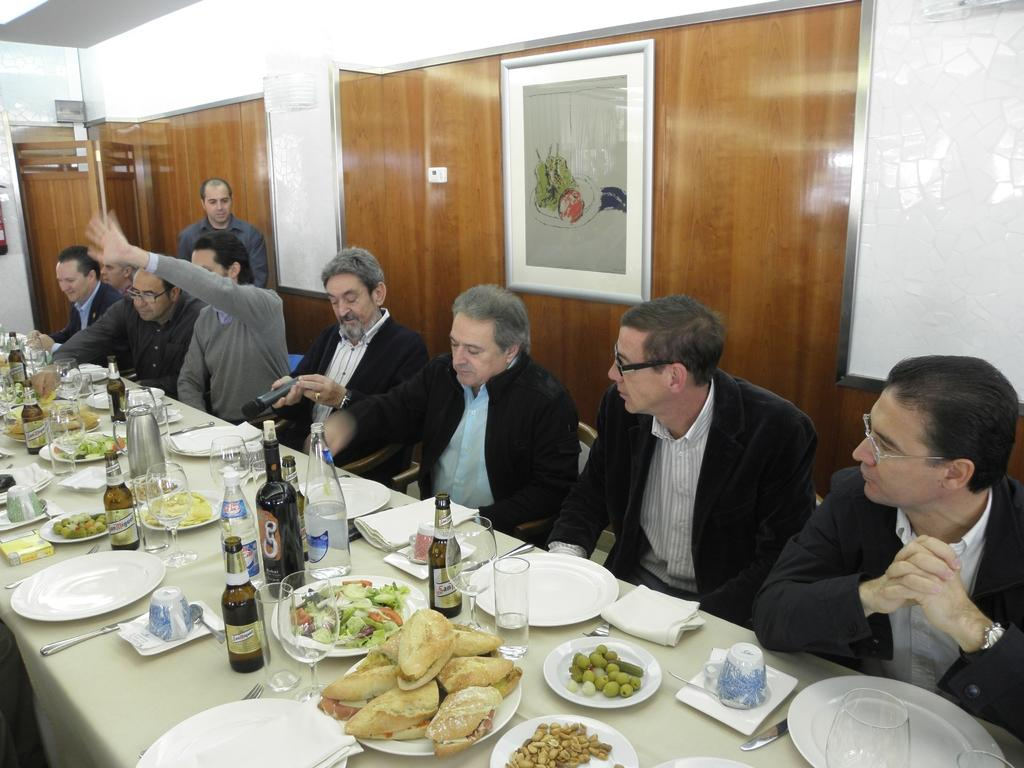How many persons are in the image? There is a group of persons in the image. What are the persons doing in the image? The persons are sitting in chairs. What can be seen on the table in the image? There is food, plates, tissues, glass bottles, and knives visible on the table. What is in the background of the image? There is a frame and a door in the background. What causes the door to open in the image? There is no indication in the image that the door is opening or closing, so it cannot be determined what causes it to move. How many seats are available for the persons in the image? The question is unclear, as the persons are already sitting in chairs. However, there appear to be enough chairs for the group of persons present. 